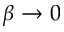Convert formula to latex. <formula><loc_0><loc_0><loc_500><loc_500>{ \beta \to 0 }</formula> 